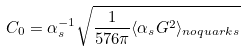<formula> <loc_0><loc_0><loc_500><loc_500>C _ { 0 } = \alpha _ { s } ^ { - 1 } \sqrt { { \frac { 1 } { 5 7 6 \pi } } \langle \alpha _ { s } G ^ { 2 } \rangle _ { n o q u a r k s } }</formula> 